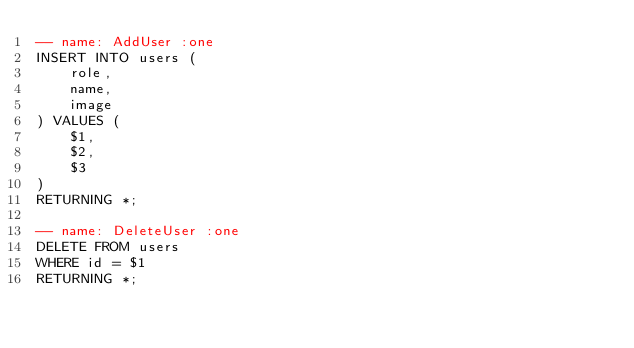Convert code to text. <code><loc_0><loc_0><loc_500><loc_500><_SQL_>-- name: AddUser :one
INSERT INTO users (
    role,
    name,
    image
) VALUES (
    $1, 
    $2,
    $3
)
RETURNING *;

-- name: DeleteUser :one
DELETE FROM users
WHERE id = $1
RETURNING *;
</code> 